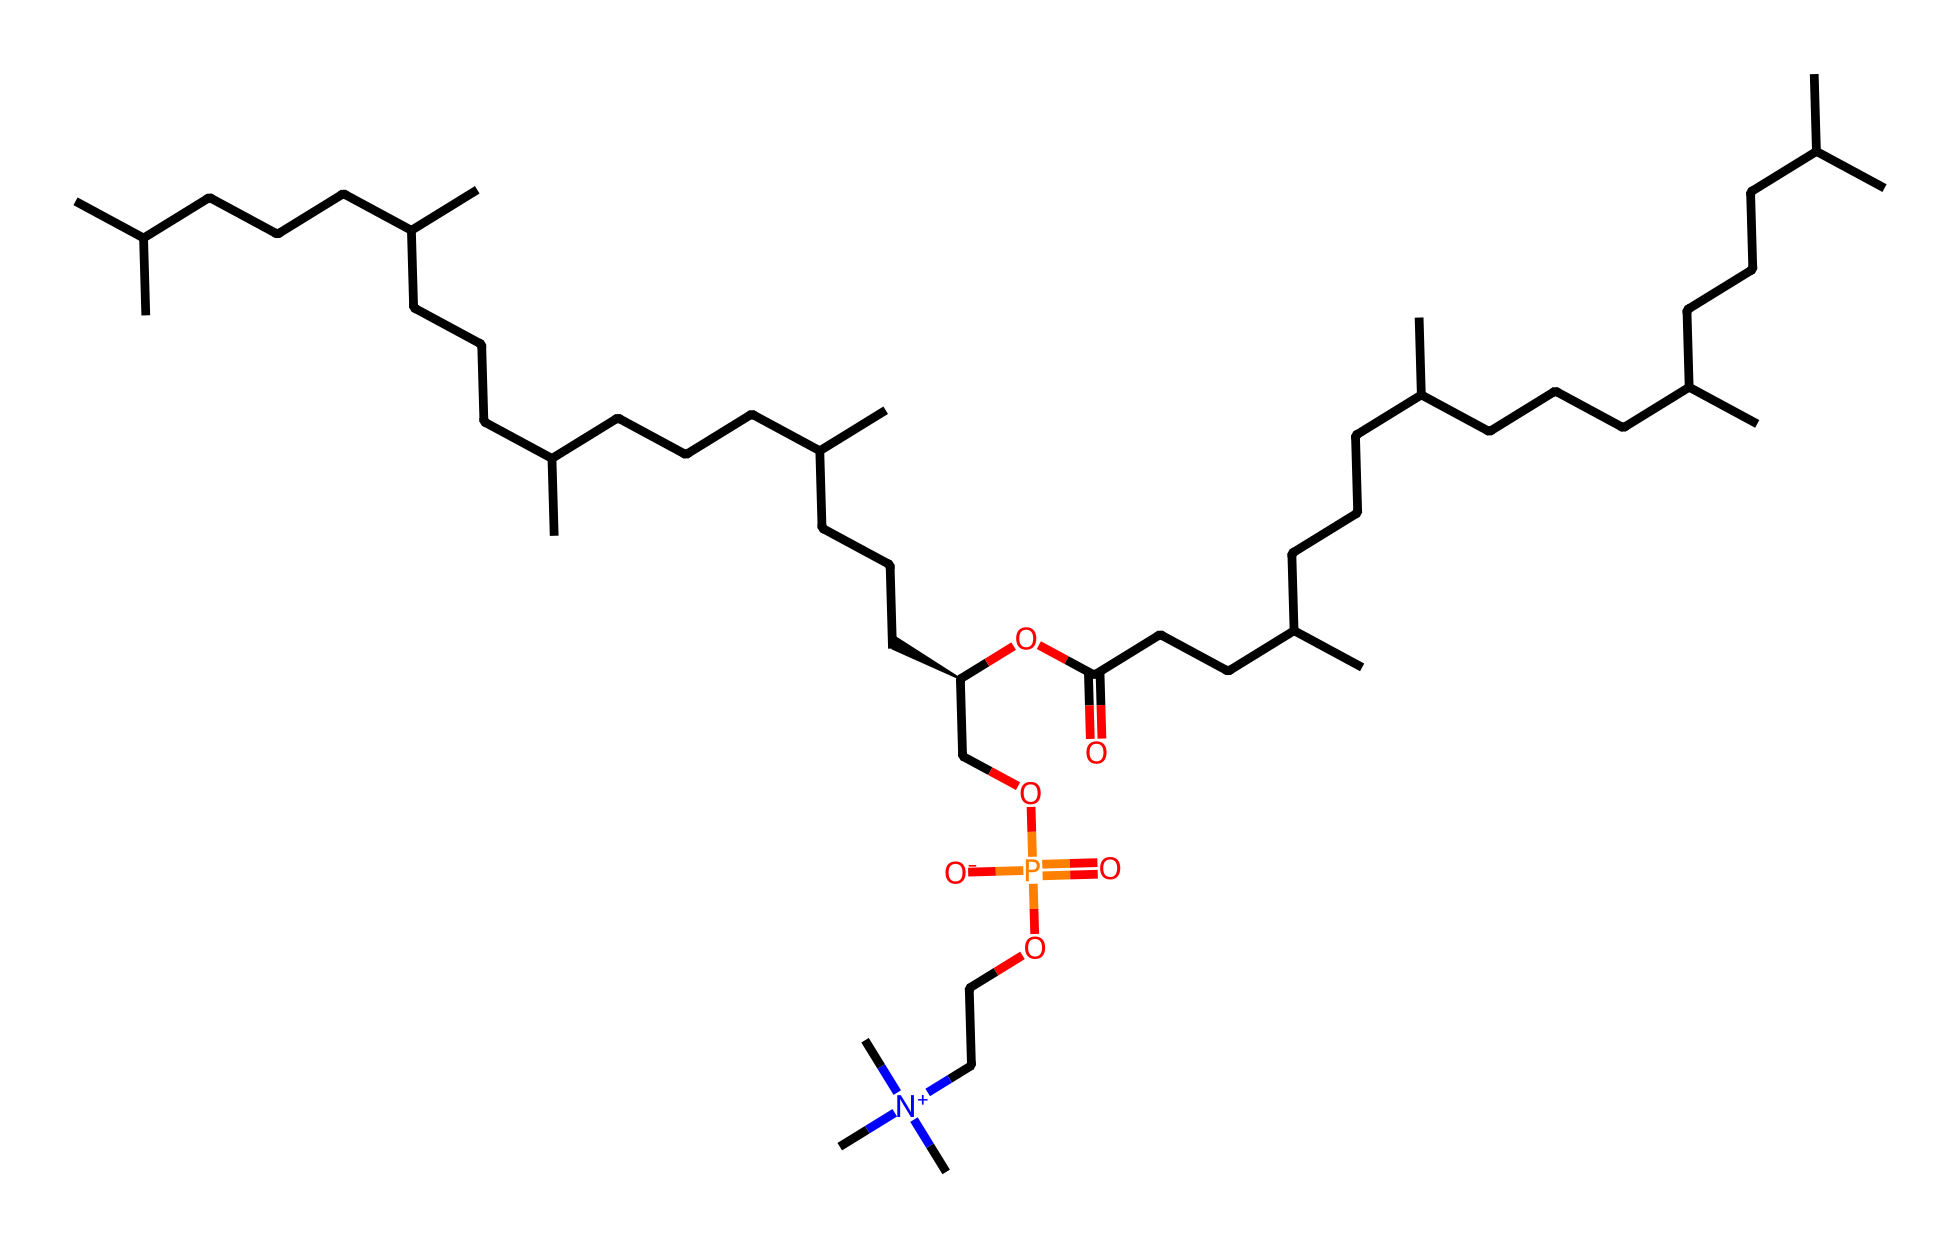What is the primary functional group present in this phospholipid? The chemical structure contains a phosphate group (COP(=O)([O-])O) which is indicative of phospholipids.
Answer: phosphate group How many carbon atoms are there in this structure? Analyzing the SMILES representation, we can count the carbon atoms present in the different parts of the structure, which totals 36 carbon atoms.
Answer: 36 What type of bond connects the fatty acid chains to the phosphatic head? The bond connecting the fatty acid chains (OC(=O)CCC) to the phosphate group is an ester bond, which forms between the hydroxyl group of the fatty acids and the carboxyl group of the phosphate.
Answer: ester bond What charge does the nitrogen in the quaternary ammonium group carry? The presence of the nitrogen atom with three methyl groups and a positive charge (N+ indicates it is positively charged) means this nitrogen is in the quaternary ammonium state.
Answer: positive How does the presence of the phosphate group influence the solubility of this lipid? The phosphate group is hydrophilic, making the overall molecule amphipathic and contributing to its solubility in water due to the polar characteristic of the phosphate group.
Answer: amphipathic What role do the long hydrocarbon chains play in the phospholipid behavior in extremophiles? The long hydrocarbon chains provide rigidity and stability to the membrane structure, which is crucial for maintaining cellular integrity under extreme environmental conditions.
Answer: rigidity and stability 